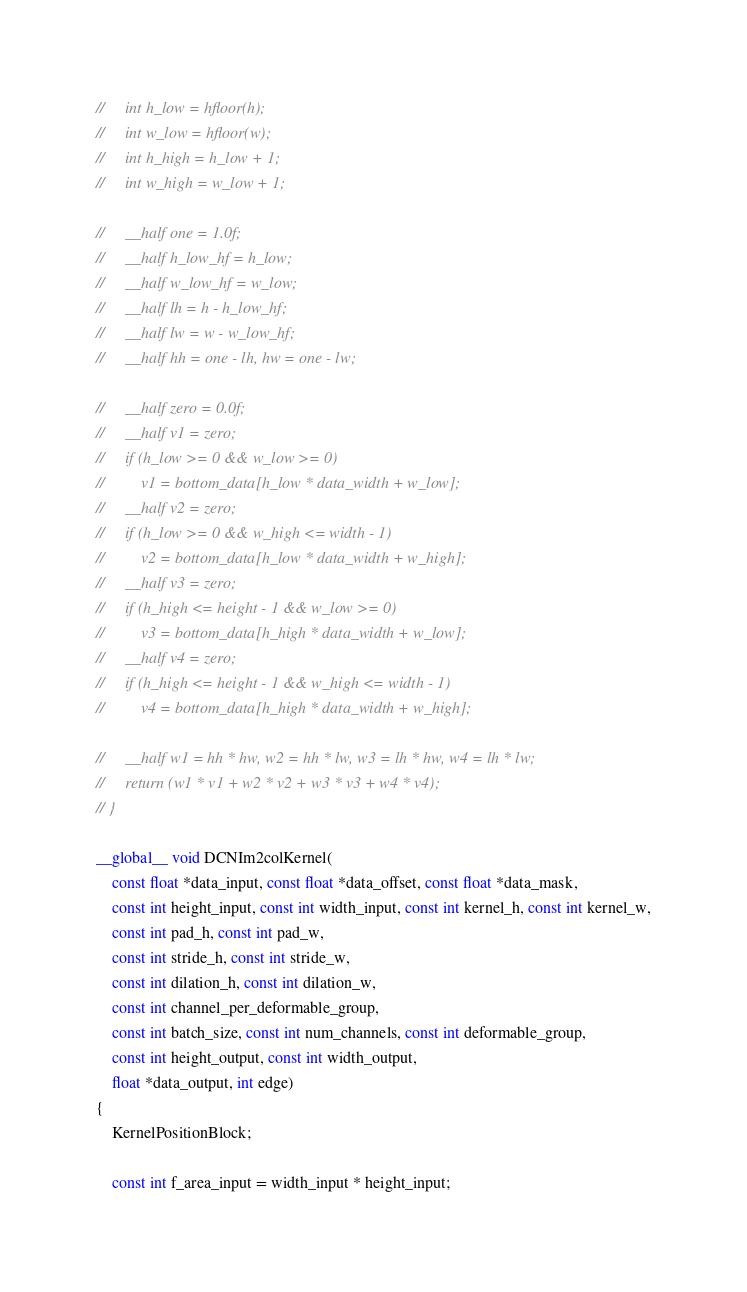<code> <loc_0><loc_0><loc_500><loc_500><_Cuda_>//     int h_low = hfloor(h);
//     int w_low = hfloor(w);
//     int h_high = h_low + 1;
//     int w_high = w_low + 1;

//     __half one = 1.0f;
//     __half h_low_hf = h_low;
//     __half w_low_hf = w_low;
//     __half lh = h - h_low_hf;
//     __half lw = w - w_low_hf;
//     __half hh = one - lh, hw = one - lw;

//     __half zero = 0.0f;
//     __half v1 = zero;
//     if (h_low >= 0 && w_low >= 0)
//         v1 = bottom_data[h_low * data_width + w_low];
//     __half v2 = zero;
//     if (h_low >= 0 && w_high <= width - 1)
//         v2 = bottom_data[h_low * data_width + w_high];
//     __half v3 = zero;
//     if (h_high <= height - 1 && w_low >= 0)
//         v3 = bottom_data[h_high * data_width + w_low];
//     __half v4 = zero;
//     if (h_high <= height - 1 && w_high <= width - 1)
//         v4 = bottom_data[h_high * data_width + w_high];

//     __half w1 = hh * hw, w2 = hh * lw, w3 = lh * hw, w4 = lh * lw;
//     return (w1 * v1 + w2 * v2 + w3 * v3 + w4 * v4);
// }

__global__ void DCNIm2colKernel(
    const float *data_input, const float *data_offset, const float *data_mask,
    const int height_input, const int width_input, const int kernel_h, const int kernel_w,
    const int pad_h, const int pad_w,
    const int stride_h, const int stride_w,
    const int dilation_h, const int dilation_w,
    const int channel_per_deformable_group,
    const int batch_size, const int num_channels, const int deformable_group,
    const int height_output, const int width_output,
    float *data_output, int edge)
{
    KernelPositionBlock;

    const int f_area_input = width_input * height_input;</code> 